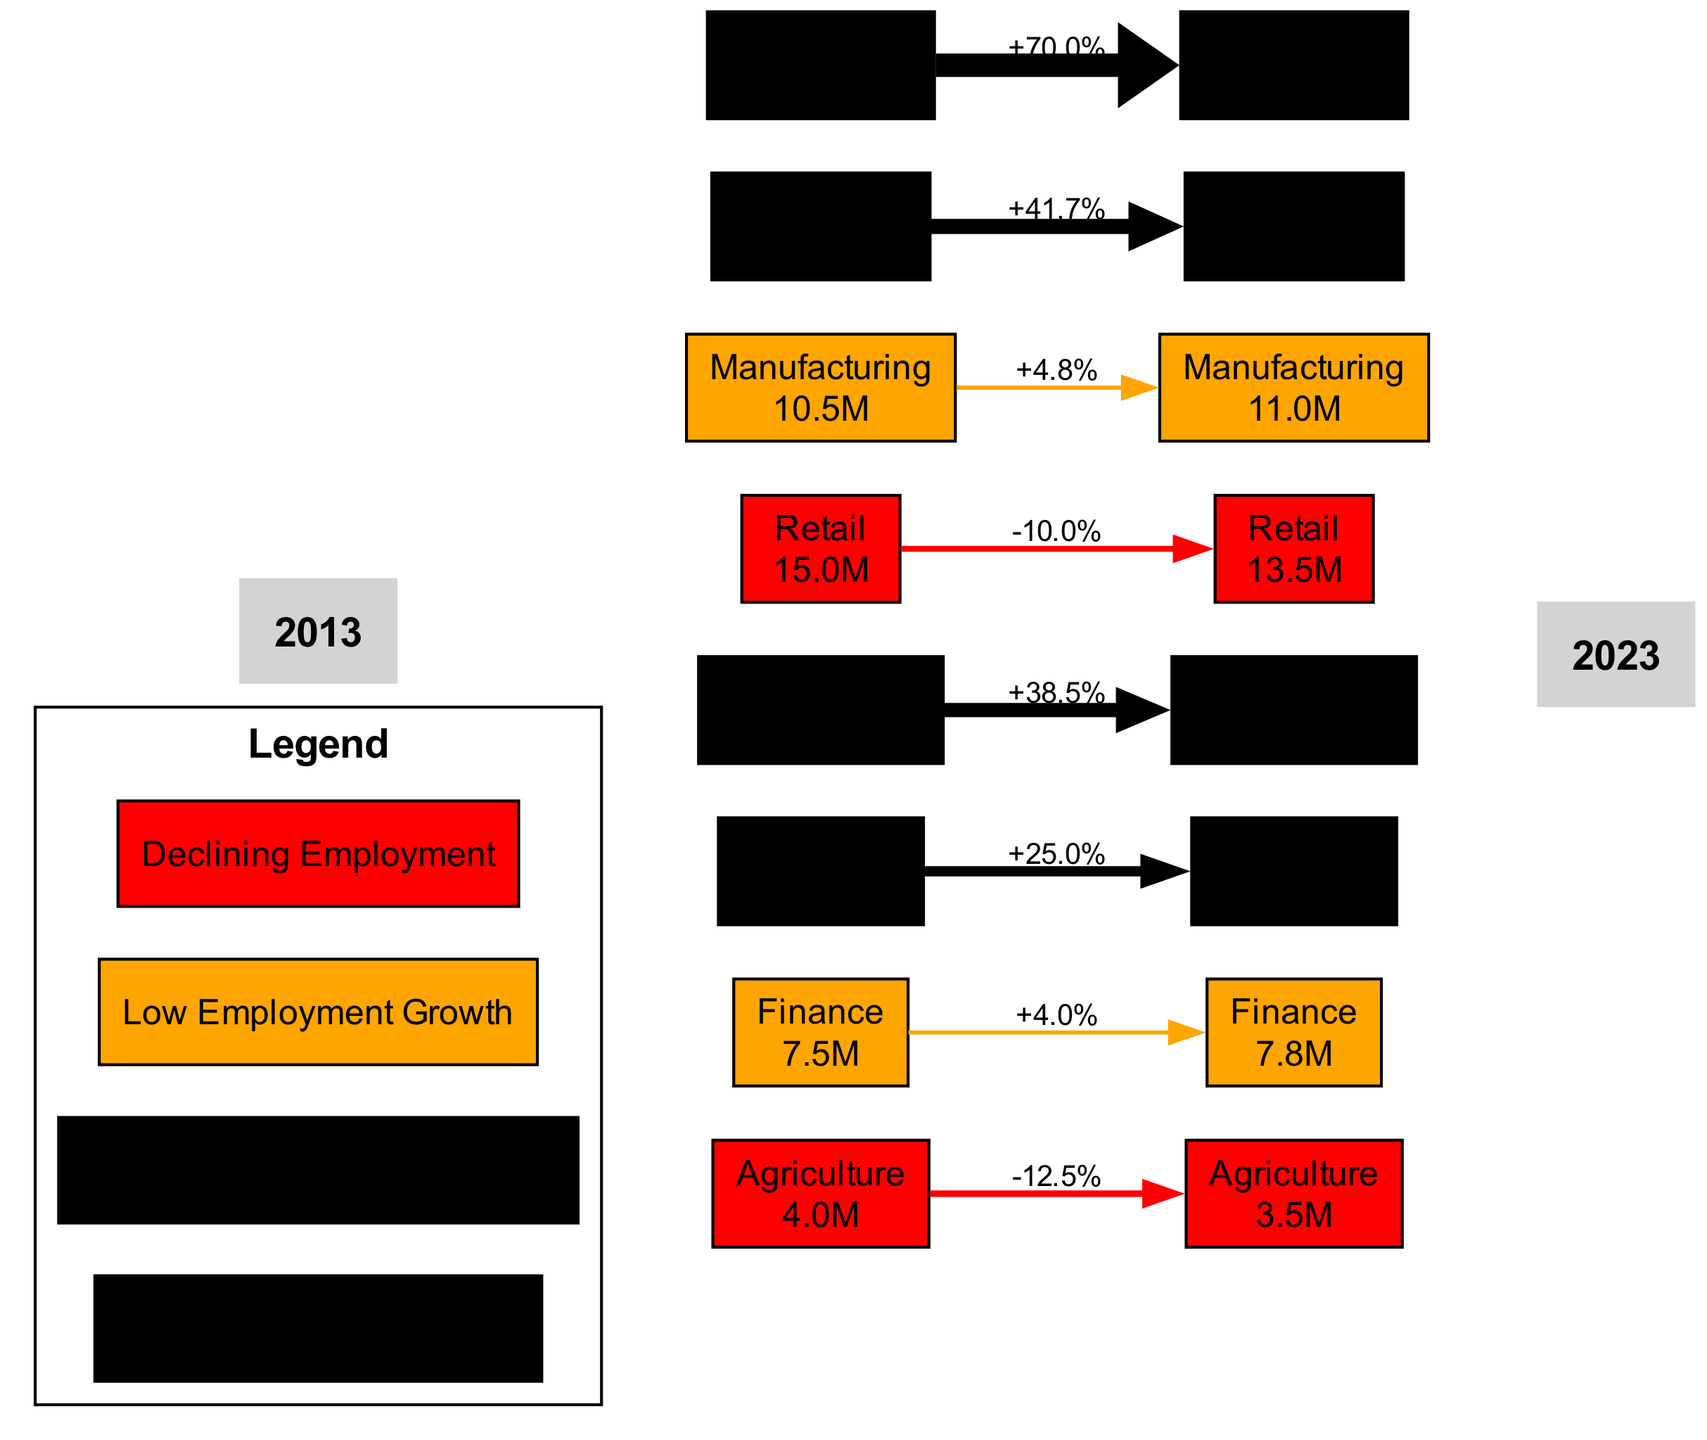What industry experienced the highest employment growth from 2013 to 2023? The diagram categorizes industries based on their employment growth trends. By looking at the color coding and node size in the "Technology" and "Healthcare" sectors, we can determine they both fall under "high_growth." Analyzing the numerical values, "Healthcare" rose from 12.0 million to 17.0 million, while "Technology" increased from 5.0 million to 8.5 million. Hence, "Healthcare" experienced the highest employment growth.
Answer: Healthcare How many industries are shown in the diagram? The diagram has a total of eight industries listed under the "industries" section. By counting the nodes directly representing distinct sectors, we conclude that there are eight.
Answer: Eight What color represents 'Declining Employment' in the heatmap? The legend defines 'Declining Employment' with a red color. By examining the color association within the diagram, it is evident that this category is represented visually by the color red.
Answer: Red What was the percentage change in employment for the Manufacturing industry? We look at the employment numbers for Manufacturing: it had 10.5 million in 2013 and 11.0 million in 2023. The percentage change is calculated as ((11.0 - 10.5) / 10.5) * 100, which equals approximately 4.76%. Thus, the answer is 4.8% when rounded to one decimal place.
Answer: 4.8% Which industry had the lowest employment in 2013? Checking the employment data from 2013 for all industries, "Agriculture" had the lowest figure at 4.0 million. By validating against the numbers listed, it confirms this industry as the one with the lowest employment.
Answer: Agriculture Which two industries are categorized as 'Moderate Employment Growth'? Referring to the color coding in the legend, we can identify that 'Moderate Employment Growth' is represented in light green. The nodes in the heatmap under this label are "Construction" and "Education." By inspecting the sectors listed, we find that they are both categorized accordingly.
Answer: Construction, Education What is the absolute value of employment in the Construction industry for 2023? The diagram provides the employment value for the Construction industry, which is noted to be 9.0 million in the year 2023. By referencing the node for this specific industry, we can find the exact figure.
Answer: 9.0 million How many industries are experiencing a decline in employment? The diagram specifically highlights 'Declining Employment' and identifies two industries, "Retail" and "Agriculture," which fall into this category. By counting the respective nodes representing these industries, we confirm there are two.
Answer: Two 